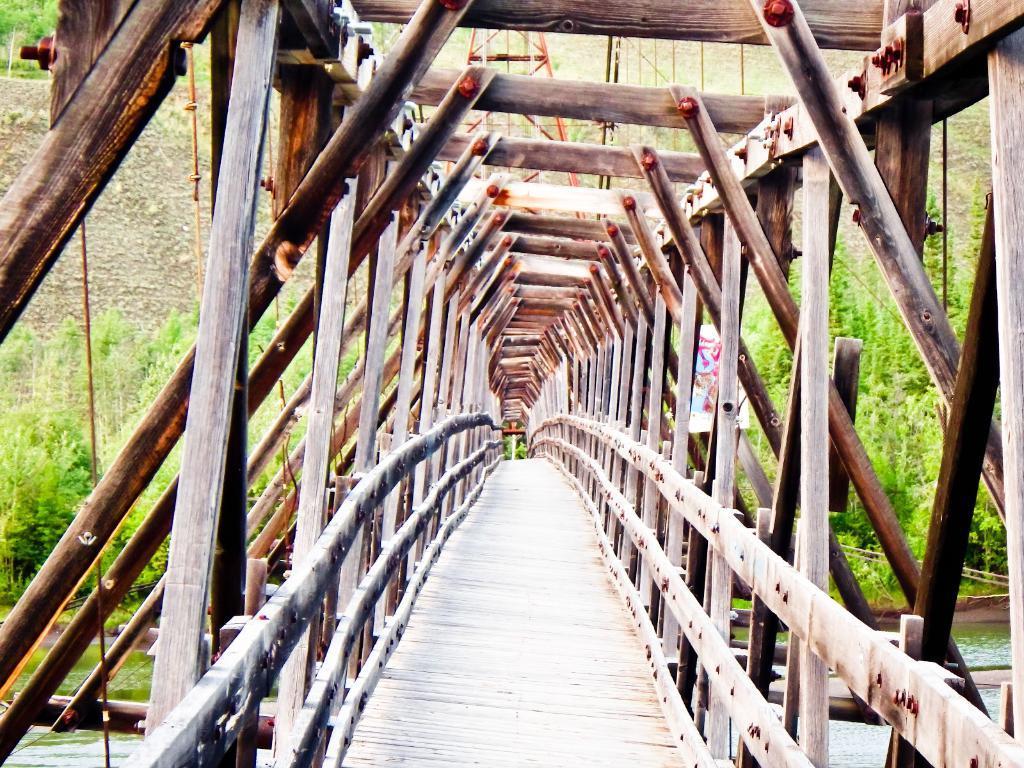Describe this image in one or two sentences. In this image we can see the wooden bench. We can also see the trees, a small banner and also the water. 